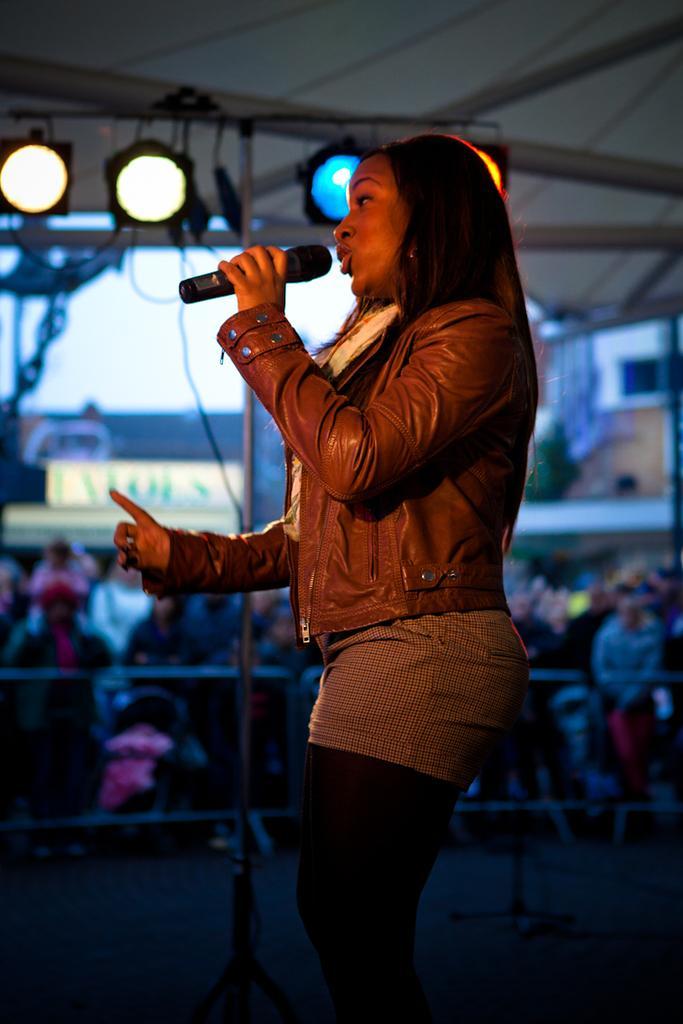In one or two sentences, can you explain what this image depicts? In this image one person is singing the song on the stage and holding the mike in front of the people there are so many persons are standing and the background is very sunny. 